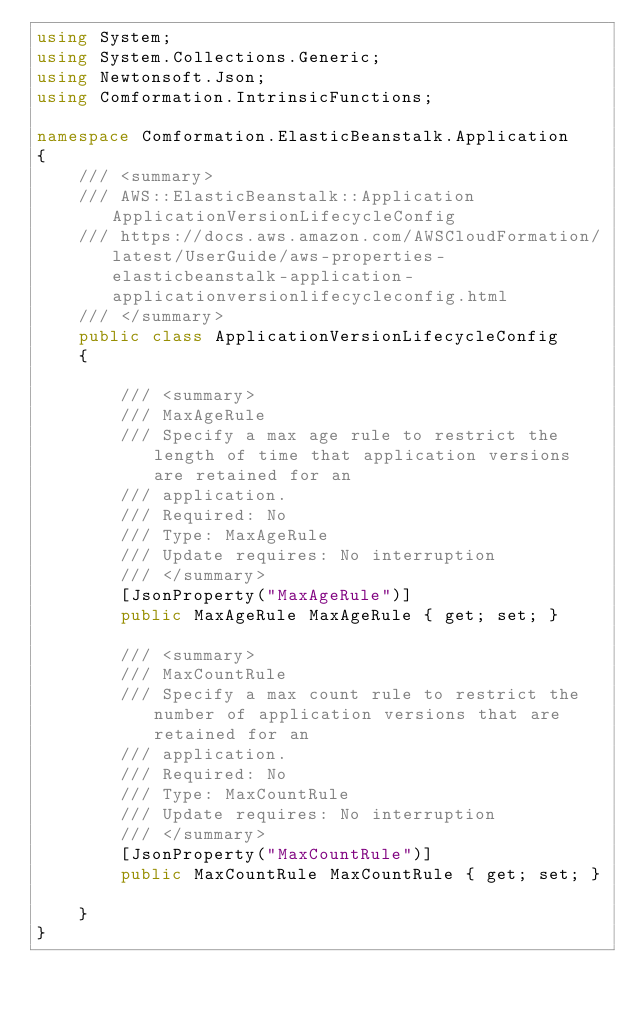Convert code to text. <code><loc_0><loc_0><loc_500><loc_500><_C#_>using System;
using System.Collections.Generic;
using Newtonsoft.Json;
using Comformation.IntrinsicFunctions;

namespace Comformation.ElasticBeanstalk.Application
{
    /// <summary>
    /// AWS::ElasticBeanstalk::Application ApplicationVersionLifecycleConfig
    /// https://docs.aws.amazon.com/AWSCloudFormation/latest/UserGuide/aws-properties-elasticbeanstalk-application-applicationversionlifecycleconfig.html
    /// </summary>
    public class ApplicationVersionLifecycleConfig
    {

        /// <summary>
        /// MaxAgeRule
        /// Specify a max age rule to restrict the length of time that application versions are retained for an
        /// application.
        /// Required: No
        /// Type: MaxAgeRule
        /// Update requires: No interruption
        /// </summary>
        [JsonProperty("MaxAgeRule")]
        public MaxAgeRule MaxAgeRule { get; set; }

        /// <summary>
        /// MaxCountRule
        /// Specify a max count rule to restrict the number of application versions that are retained for an
        /// application.
        /// Required: No
        /// Type: MaxCountRule
        /// Update requires: No interruption
        /// </summary>
        [JsonProperty("MaxCountRule")]
        public MaxCountRule MaxCountRule { get; set; }

    }
}
</code> 